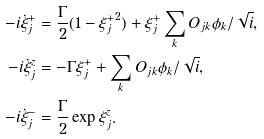<formula> <loc_0><loc_0><loc_500><loc_500>- i \dot { \xi } ^ { + } _ { j } & = \frac { \Gamma } { 2 } ( 1 - { \xi ^ { + } _ { j } } ^ { 2 } ) + \xi ^ { + } _ { j } \sum _ { k } O _ { j k } \phi _ { k } / \sqrt { i } , \\ - i \dot { \xi } ^ { z } _ { j } & = - \Gamma \xi ^ { + } _ { j } + \sum _ { k } O _ { j k } \phi _ { k } / \sqrt { i } , \\ - i \dot { \xi } ^ { - } _ { j } & = \frac { \Gamma } { 2 } \exp { \xi ^ { z } _ { j } } .</formula> 